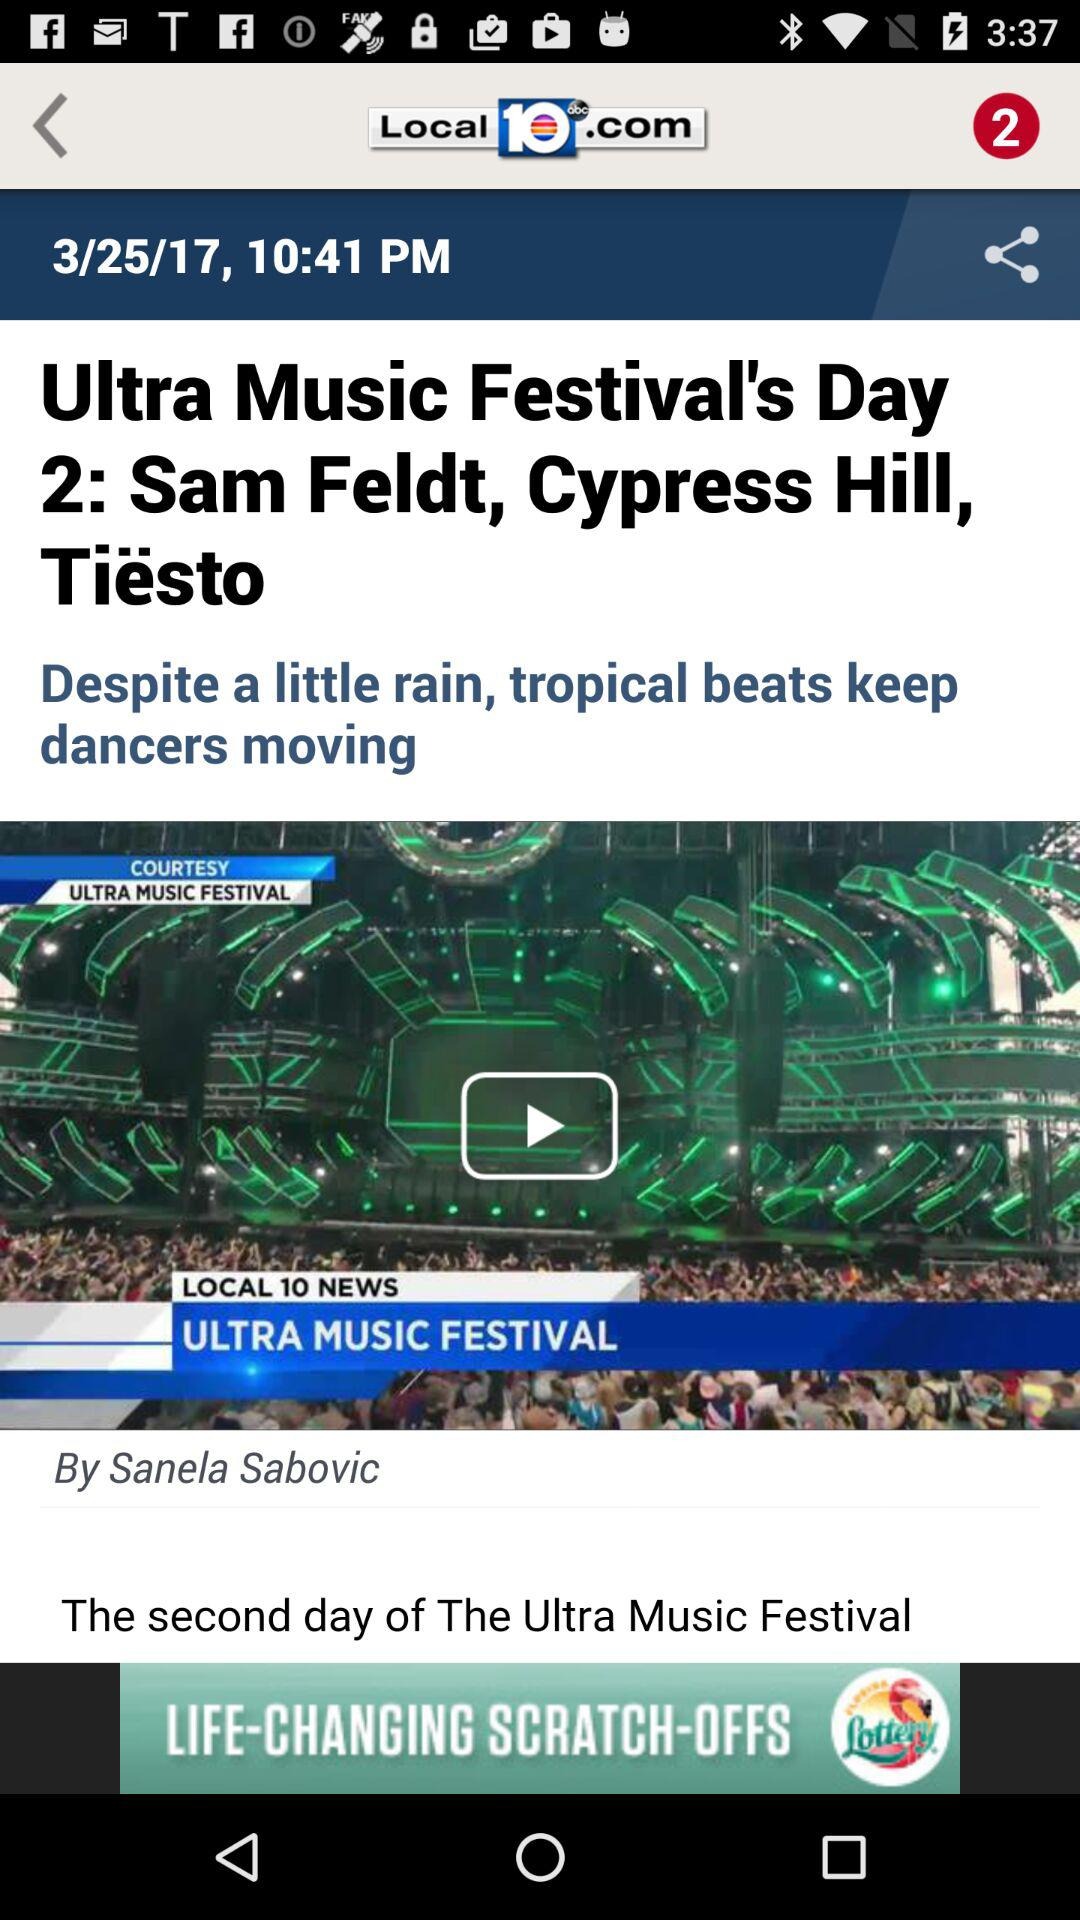How many notifications are now displayed? There are 2 notifications displayed. 